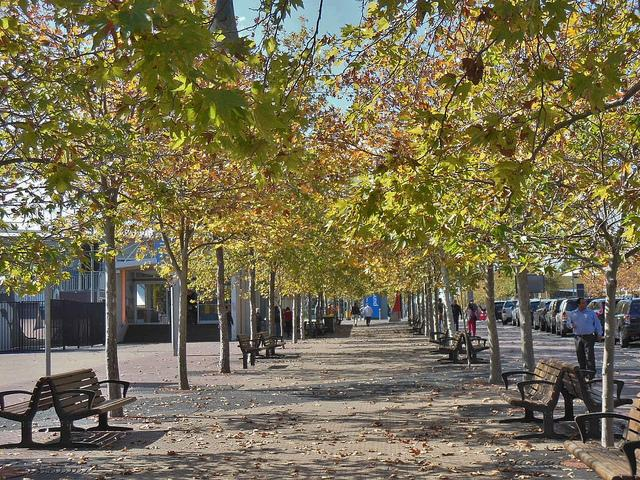What season of the year is it? fall 